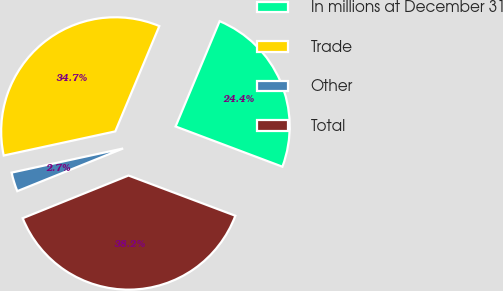<chart> <loc_0><loc_0><loc_500><loc_500><pie_chart><fcel>In millions at December 31<fcel>Trade<fcel>Other<fcel>Total<nl><fcel>24.43%<fcel>34.7%<fcel>2.71%<fcel>38.17%<nl></chart> 